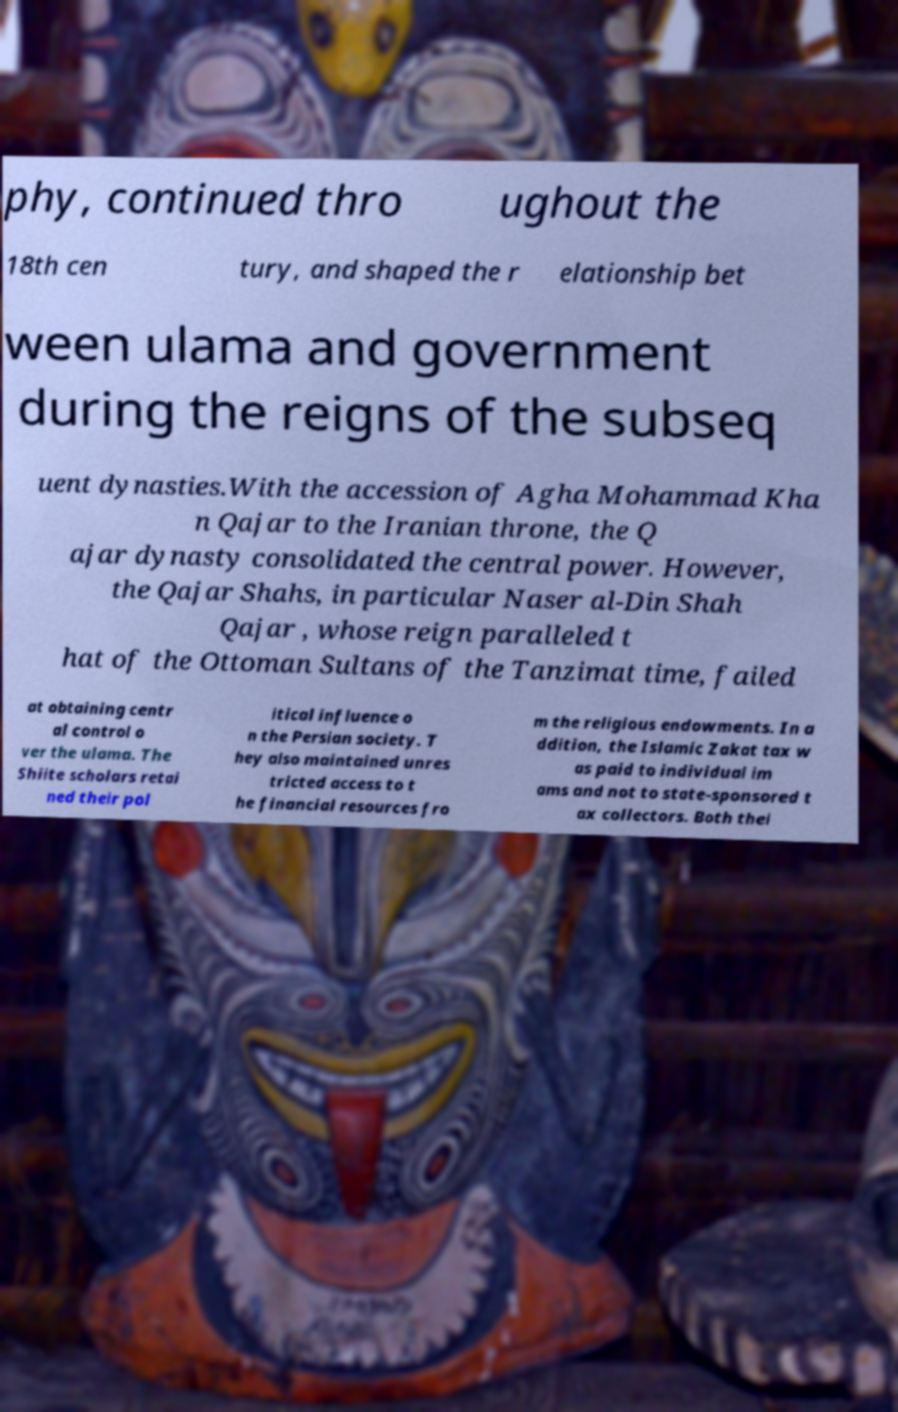Please read and relay the text visible in this image. What does it say? phy, continued thro ughout the 18th cen tury, and shaped the r elationship bet ween ulama and government during the reigns of the subseq uent dynasties.With the accession of Agha Mohammad Kha n Qajar to the Iranian throne, the Q ajar dynasty consolidated the central power. However, the Qajar Shahs, in particular Naser al-Din Shah Qajar , whose reign paralleled t hat of the Ottoman Sultans of the Tanzimat time, failed at obtaining centr al control o ver the ulama. The Shiite scholars retai ned their pol itical influence o n the Persian society. T hey also maintained unres tricted access to t he financial resources fro m the religious endowments. In a ddition, the Islamic Zakat tax w as paid to individual im ams and not to state-sponsored t ax collectors. Both thei 